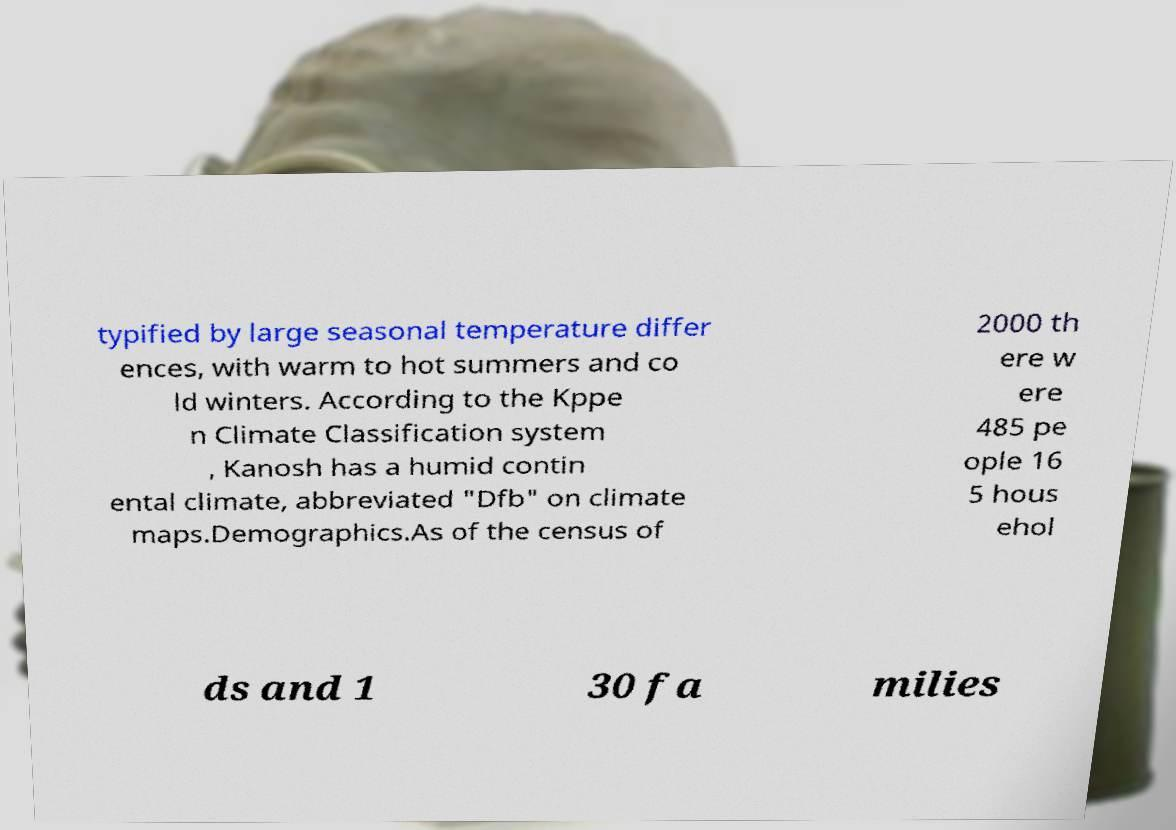I need the written content from this picture converted into text. Can you do that? typified by large seasonal temperature differ ences, with warm to hot summers and co ld winters. According to the Kppe n Climate Classification system , Kanosh has a humid contin ental climate, abbreviated "Dfb" on climate maps.Demographics.As of the census of 2000 th ere w ere 485 pe ople 16 5 hous ehol ds and 1 30 fa milies 